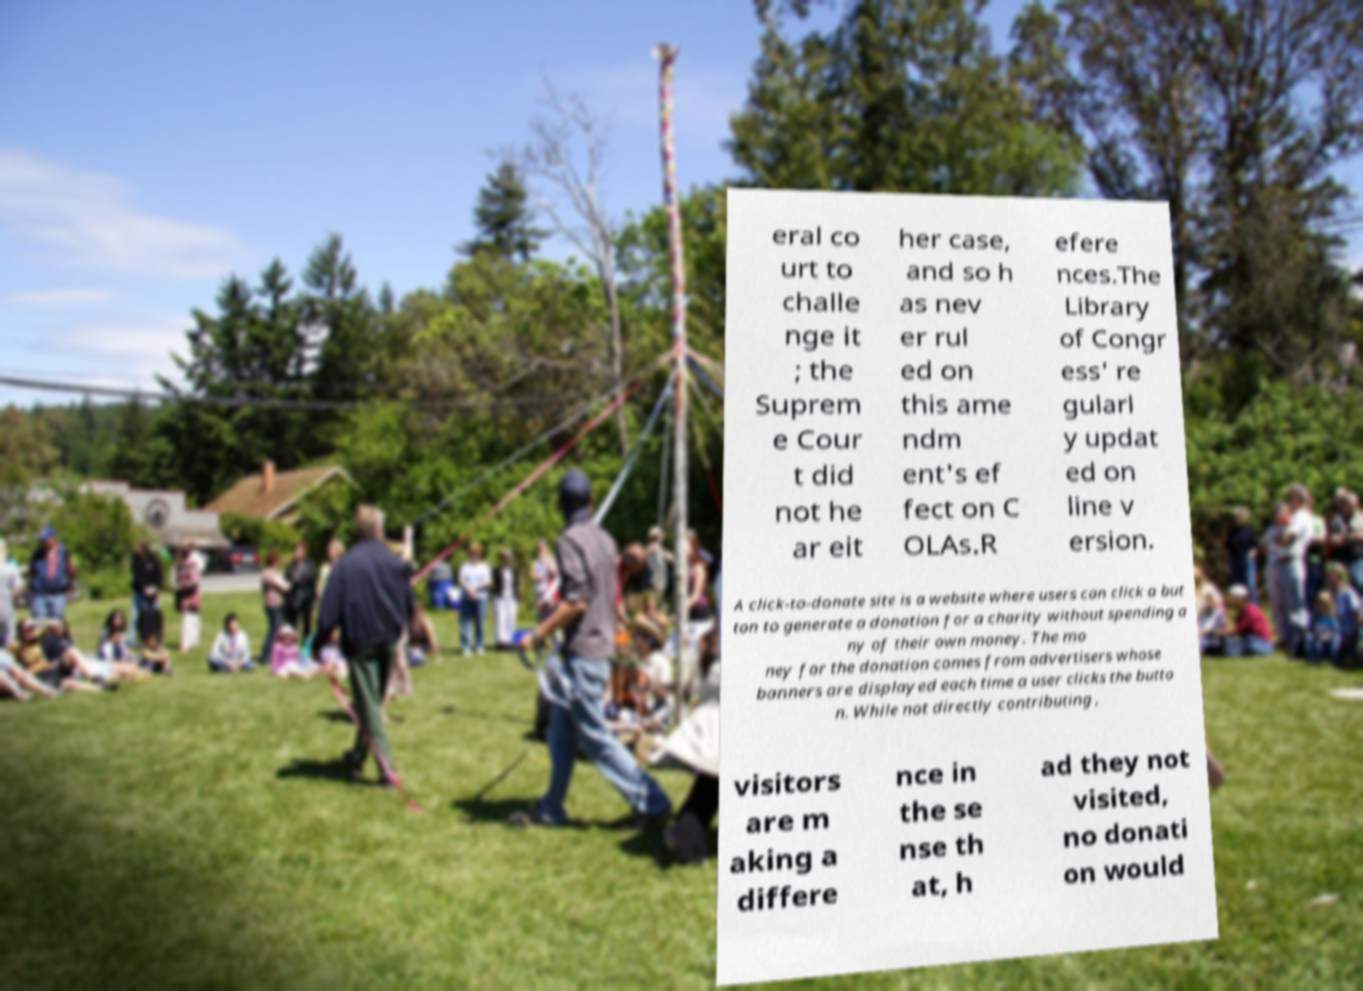I need the written content from this picture converted into text. Can you do that? eral co urt to challe nge it ; the Suprem e Cour t did not he ar eit her case, and so h as nev er rul ed on this ame ndm ent's ef fect on C OLAs.R efere nces.The Library of Congr ess' re gularl y updat ed on line v ersion. A click-to-donate site is a website where users can click a but ton to generate a donation for a charity without spending a ny of their own money. The mo ney for the donation comes from advertisers whose banners are displayed each time a user clicks the butto n. While not directly contributing , visitors are m aking a differe nce in the se nse th at, h ad they not visited, no donati on would 